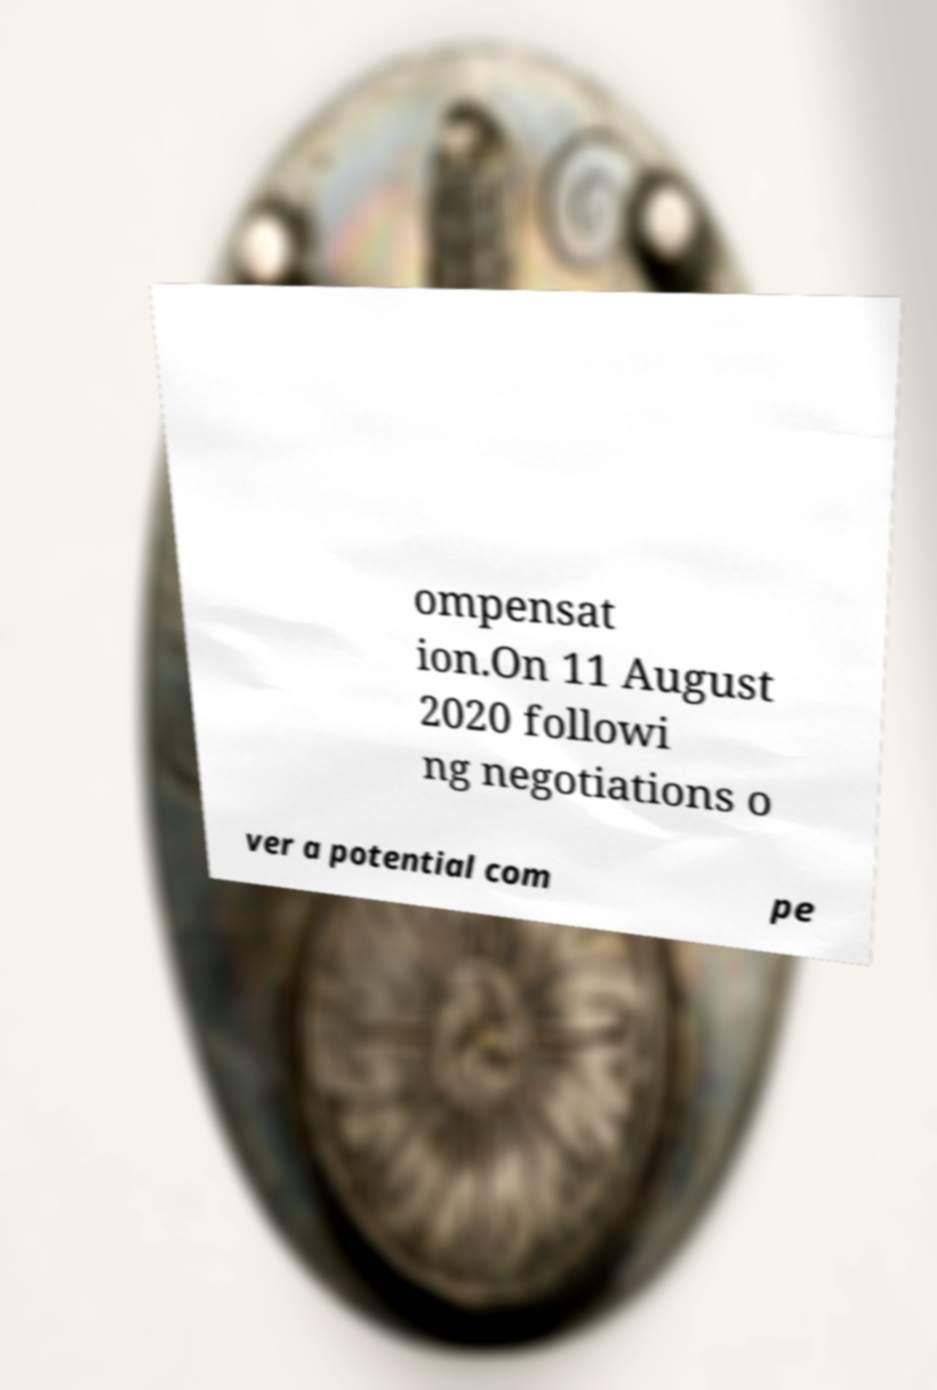Please read and relay the text visible in this image. What does it say? ompensat ion.On 11 August 2020 followi ng negotiations o ver a potential com pe 